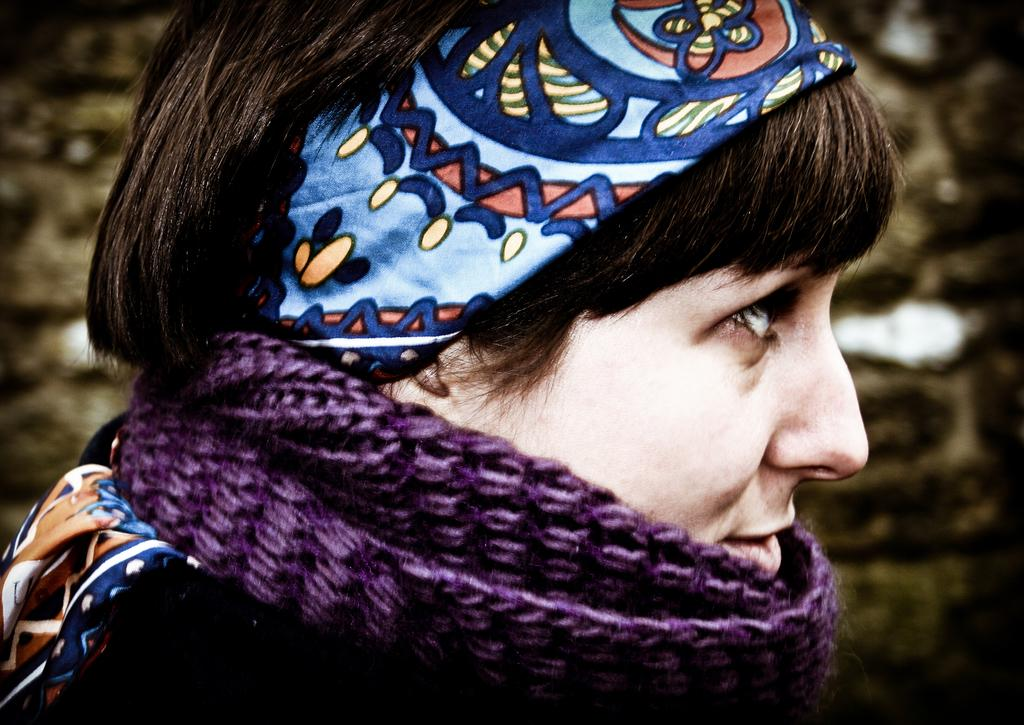Who is the main subject in the image? There is a woman in the image. Can you describe the background of the image? The background of the image is blurry. What type of glass is the woman holding in the image? There is no glass present in the image; the woman is the only subject visible. 